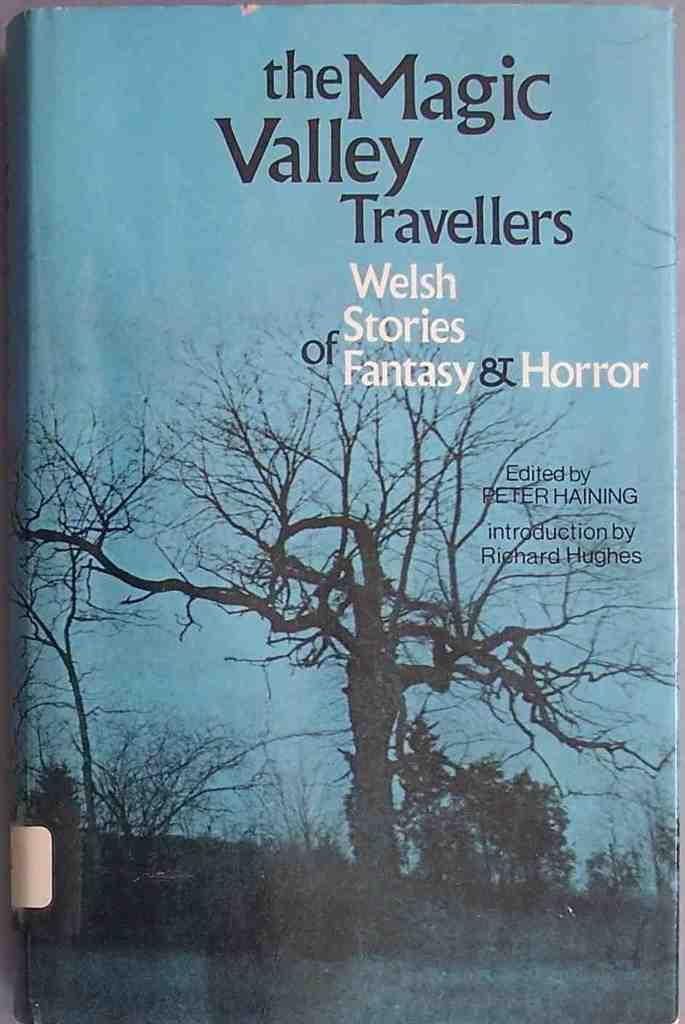<image>
Provide a brief description of the given image. A book cover for the magic valley traveller. 